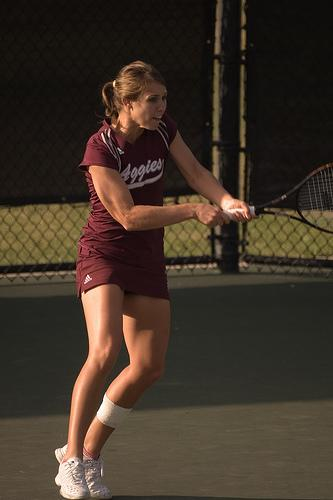Pose a multiple choice question about the woman's attire and provide the correct answer. Correct Answer: B) Red What type of clothing does the woman in the picture wear? The woman is wearing a red jersey and shorts, white sneakers, and has a hair tie and a ponytail. Create an inquiry about the woman's hair and provide the correct response. Answer: The woman's hair is tied up with a hair tie, and she sports a ponytail. Identify the primary activity taking place in the image. A woman playing tennis on a court, preparing to hit the ball with her racket. What is the purpose of the white bandage on the woman's calf? The white bandage on her calf is to provide support and stability while she plays tennis, preventing injuries. Describe the surface and surroundings of the tennis court in the picture. The ground of the tennis court is marked with white lines and has a shadow casted on it. A metal gate and fence surround the court, and there are metal poles near one edge. Write a question that requires critical thinking about the image and give the answer. Answer: The woman's focused expression, combined with her confident posture and grip on the tennis racket, suggests a strong determination to win the match. Compose an advertisement for endorsing the woman's tennis racket seen in the image. Introducing the ultimate tennis racket for champions! Our black racket, showcased by this pro athlete, features a comfortable white handle that ensures optimum control and power. Elevate your game with an unbeatable performance today! In a conversational tone, describe the objects found on the tennis court in the given image. Hey, you know what? In this photo, there's a woman playing tennis on a court, holding a racket with a white handle! Her outfit has logos and words on it, and she's wearing white sneakers with laces. The court also has a metal gate and a fence. 